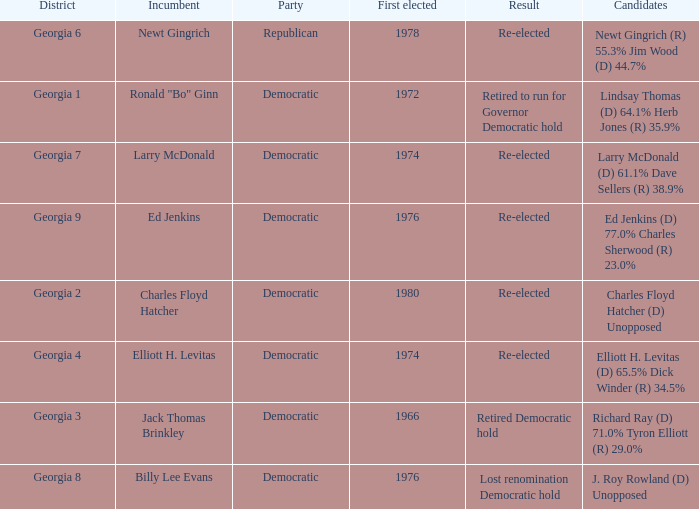Specify the area for larry mcdonald. Georgia 7. 